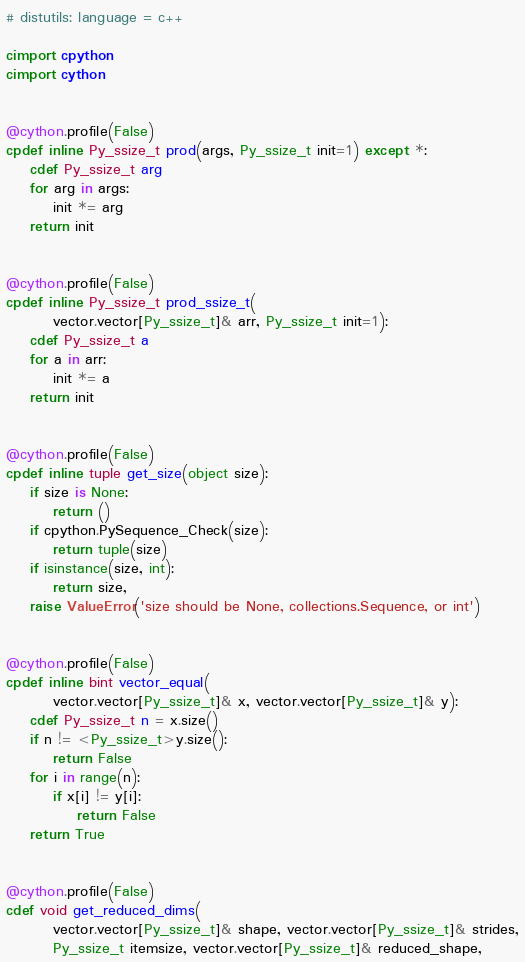<code> <loc_0><loc_0><loc_500><loc_500><_Cython_># distutils: language = c++

cimport cpython
cimport cython


@cython.profile(False)
cpdef inline Py_ssize_t prod(args, Py_ssize_t init=1) except *:
    cdef Py_ssize_t arg
    for arg in args:
        init *= arg
    return init


@cython.profile(False)
cpdef inline Py_ssize_t prod_ssize_t(
        vector.vector[Py_ssize_t]& arr, Py_ssize_t init=1):
    cdef Py_ssize_t a
    for a in arr:
        init *= a
    return init


@cython.profile(False)
cpdef inline tuple get_size(object size):
    if size is None:
        return ()
    if cpython.PySequence_Check(size):
        return tuple(size)
    if isinstance(size, int):
        return size,
    raise ValueError('size should be None, collections.Sequence, or int')


@cython.profile(False)
cpdef inline bint vector_equal(
        vector.vector[Py_ssize_t]& x, vector.vector[Py_ssize_t]& y):
    cdef Py_ssize_t n = x.size()
    if n != <Py_ssize_t>y.size():
        return False
    for i in range(n):
        if x[i] != y[i]:
            return False
    return True


@cython.profile(False)
cdef void get_reduced_dims(
        vector.vector[Py_ssize_t]& shape, vector.vector[Py_ssize_t]& strides,
        Py_ssize_t itemsize, vector.vector[Py_ssize_t]& reduced_shape,</code> 